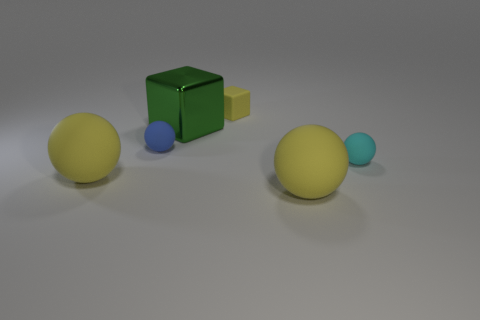Subtract 2 spheres. How many spheres are left? 2 Add 1 green things. How many objects exist? 7 Subtract all spheres. How many objects are left? 2 Subtract 0 cyan cylinders. How many objects are left? 6 Subtract all small brown rubber blocks. Subtract all big balls. How many objects are left? 4 Add 6 balls. How many balls are left? 10 Add 5 tiny yellow balls. How many tiny yellow balls exist? 5 